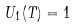Convert formula to latex. <formula><loc_0><loc_0><loc_500><loc_500>U _ { 1 } ( T ) = 1</formula> 